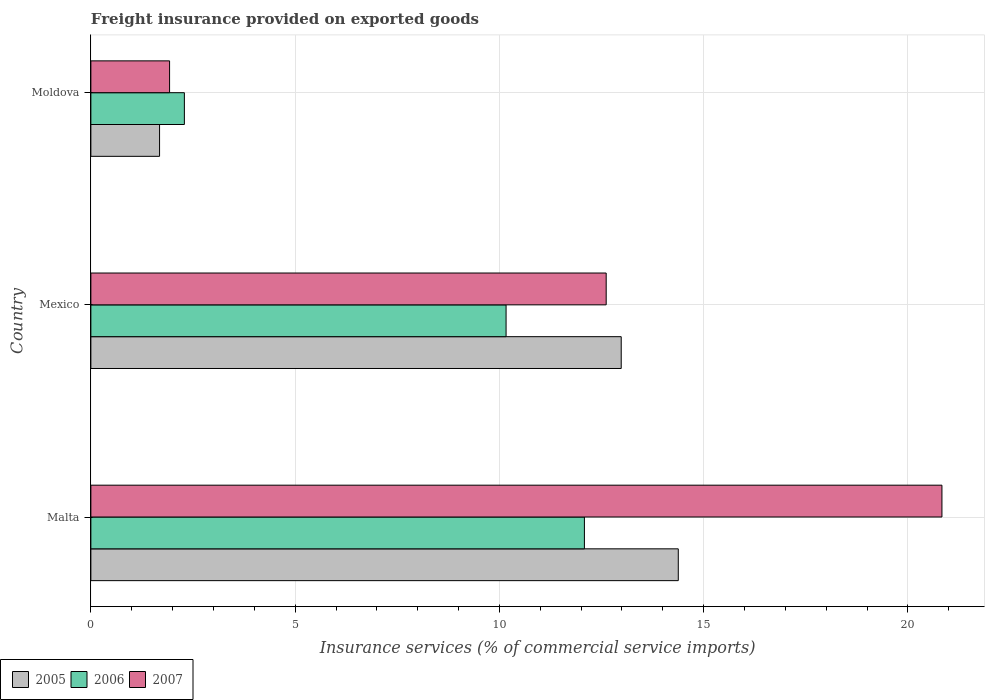How many different coloured bars are there?
Make the answer very short. 3. How many groups of bars are there?
Offer a very short reply. 3. Are the number of bars per tick equal to the number of legend labels?
Keep it short and to the point. Yes. How many bars are there on the 2nd tick from the top?
Keep it short and to the point. 3. How many bars are there on the 3rd tick from the bottom?
Your answer should be compact. 3. What is the label of the 1st group of bars from the top?
Provide a succinct answer. Moldova. In how many cases, is the number of bars for a given country not equal to the number of legend labels?
Give a very brief answer. 0. What is the freight insurance provided on exported goods in 2005 in Mexico?
Your response must be concise. 12.98. Across all countries, what is the maximum freight insurance provided on exported goods in 2006?
Offer a very short reply. 12.08. Across all countries, what is the minimum freight insurance provided on exported goods in 2007?
Ensure brevity in your answer.  1.93. In which country was the freight insurance provided on exported goods in 2007 maximum?
Ensure brevity in your answer.  Malta. In which country was the freight insurance provided on exported goods in 2006 minimum?
Your answer should be compact. Moldova. What is the total freight insurance provided on exported goods in 2006 in the graph?
Offer a terse response. 24.53. What is the difference between the freight insurance provided on exported goods in 2006 in Malta and that in Mexico?
Make the answer very short. 1.92. What is the difference between the freight insurance provided on exported goods in 2007 in Moldova and the freight insurance provided on exported goods in 2005 in Malta?
Keep it short and to the point. -12.45. What is the average freight insurance provided on exported goods in 2006 per country?
Offer a very short reply. 8.18. What is the difference between the freight insurance provided on exported goods in 2005 and freight insurance provided on exported goods in 2007 in Malta?
Make the answer very short. -6.45. In how many countries, is the freight insurance provided on exported goods in 2007 greater than 9 %?
Your answer should be compact. 2. What is the ratio of the freight insurance provided on exported goods in 2007 in Malta to that in Mexico?
Give a very brief answer. 1.65. What is the difference between the highest and the second highest freight insurance provided on exported goods in 2005?
Ensure brevity in your answer.  1.4. What is the difference between the highest and the lowest freight insurance provided on exported goods in 2006?
Ensure brevity in your answer.  9.79. In how many countries, is the freight insurance provided on exported goods in 2005 greater than the average freight insurance provided on exported goods in 2005 taken over all countries?
Ensure brevity in your answer.  2. What does the 3rd bar from the top in Moldova represents?
Provide a succinct answer. 2005. What does the 3rd bar from the bottom in Mexico represents?
Keep it short and to the point. 2007. How many bars are there?
Keep it short and to the point. 9. Does the graph contain any zero values?
Provide a succinct answer. No. Does the graph contain grids?
Your answer should be compact. Yes. What is the title of the graph?
Provide a succinct answer. Freight insurance provided on exported goods. Does "1989" appear as one of the legend labels in the graph?
Ensure brevity in your answer.  No. What is the label or title of the X-axis?
Keep it short and to the point. Insurance services (% of commercial service imports). What is the Insurance services (% of commercial service imports) in 2005 in Malta?
Offer a terse response. 14.38. What is the Insurance services (% of commercial service imports) of 2006 in Malta?
Keep it short and to the point. 12.08. What is the Insurance services (% of commercial service imports) in 2007 in Malta?
Your answer should be compact. 20.83. What is the Insurance services (% of commercial service imports) of 2005 in Mexico?
Provide a short and direct response. 12.98. What is the Insurance services (% of commercial service imports) of 2006 in Mexico?
Your answer should be compact. 10.16. What is the Insurance services (% of commercial service imports) in 2007 in Mexico?
Ensure brevity in your answer.  12.61. What is the Insurance services (% of commercial service imports) in 2005 in Moldova?
Offer a very short reply. 1.68. What is the Insurance services (% of commercial service imports) of 2006 in Moldova?
Your answer should be very brief. 2.29. What is the Insurance services (% of commercial service imports) of 2007 in Moldova?
Ensure brevity in your answer.  1.93. Across all countries, what is the maximum Insurance services (% of commercial service imports) in 2005?
Make the answer very short. 14.38. Across all countries, what is the maximum Insurance services (% of commercial service imports) of 2006?
Your answer should be compact. 12.08. Across all countries, what is the maximum Insurance services (% of commercial service imports) of 2007?
Offer a very short reply. 20.83. Across all countries, what is the minimum Insurance services (% of commercial service imports) of 2005?
Your response must be concise. 1.68. Across all countries, what is the minimum Insurance services (% of commercial service imports) of 2006?
Provide a succinct answer. 2.29. Across all countries, what is the minimum Insurance services (% of commercial service imports) in 2007?
Your response must be concise. 1.93. What is the total Insurance services (% of commercial service imports) in 2005 in the graph?
Your answer should be very brief. 29.04. What is the total Insurance services (% of commercial service imports) of 2006 in the graph?
Ensure brevity in your answer.  24.53. What is the total Insurance services (% of commercial service imports) of 2007 in the graph?
Keep it short and to the point. 35.37. What is the difference between the Insurance services (% of commercial service imports) in 2005 in Malta and that in Mexico?
Provide a succinct answer. 1.4. What is the difference between the Insurance services (% of commercial service imports) in 2006 in Malta and that in Mexico?
Offer a very short reply. 1.92. What is the difference between the Insurance services (% of commercial service imports) of 2007 in Malta and that in Mexico?
Offer a very short reply. 8.22. What is the difference between the Insurance services (% of commercial service imports) in 2005 in Malta and that in Moldova?
Make the answer very short. 12.7. What is the difference between the Insurance services (% of commercial service imports) of 2006 in Malta and that in Moldova?
Offer a terse response. 9.79. What is the difference between the Insurance services (% of commercial service imports) in 2007 in Malta and that in Moldova?
Provide a short and direct response. 18.91. What is the difference between the Insurance services (% of commercial service imports) in 2005 in Mexico and that in Moldova?
Your response must be concise. 11.3. What is the difference between the Insurance services (% of commercial service imports) of 2006 in Mexico and that in Moldova?
Ensure brevity in your answer.  7.87. What is the difference between the Insurance services (% of commercial service imports) in 2007 in Mexico and that in Moldova?
Offer a terse response. 10.69. What is the difference between the Insurance services (% of commercial service imports) of 2005 in Malta and the Insurance services (% of commercial service imports) of 2006 in Mexico?
Ensure brevity in your answer.  4.22. What is the difference between the Insurance services (% of commercial service imports) in 2005 in Malta and the Insurance services (% of commercial service imports) in 2007 in Mexico?
Provide a succinct answer. 1.76. What is the difference between the Insurance services (% of commercial service imports) in 2006 in Malta and the Insurance services (% of commercial service imports) in 2007 in Mexico?
Your response must be concise. -0.53. What is the difference between the Insurance services (% of commercial service imports) in 2005 in Malta and the Insurance services (% of commercial service imports) in 2006 in Moldova?
Give a very brief answer. 12.09. What is the difference between the Insurance services (% of commercial service imports) in 2005 in Malta and the Insurance services (% of commercial service imports) in 2007 in Moldova?
Ensure brevity in your answer.  12.45. What is the difference between the Insurance services (% of commercial service imports) of 2006 in Malta and the Insurance services (% of commercial service imports) of 2007 in Moldova?
Provide a short and direct response. 10.15. What is the difference between the Insurance services (% of commercial service imports) of 2005 in Mexico and the Insurance services (% of commercial service imports) of 2006 in Moldova?
Provide a short and direct response. 10.69. What is the difference between the Insurance services (% of commercial service imports) of 2005 in Mexico and the Insurance services (% of commercial service imports) of 2007 in Moldova?
Keep it short and to the point. 11.06. What is the difference between the Insurance services (% of commercial service imports) in 2006 in Mexico and the Insurance services (% of commercial service imports) in 2007 in Moldova?
Your answer should be compact. 8.24. What is the average Insurance services (% of commercial service imports) in 2005 per country?
Ensure brevity in your answer.  9.68. What is the average Insurance services (% of commercial service imports) in 2006 per country?
Ensure brevity in your answer.  8.18. What is the average Insurance services (% of commercial service imports) of 2007 per country?
Ensure brevity in your answer.  11.79. What is the difference between the Insurance services (% of commercial service imports) of 2005 and Insurance services (% of commercial service imports) of 2006 in Malta?
Offer a very short reply. 2.3. What is the difference between the Insurance services (% of commercial service imports) of 2005 and Insurance services (% of commercial service imports) of 2007 in Malta?
Your answer should be very brief. -6.45. What is the difference between the Insurance services (% of commercial service imports) of 2006 and Insurance services (% of commercial service imports) of 2007 in Malta?
Your answer should be very brief. -8.75. What is the difference between the Insurance services (% of commercial service imports) of 2005 and Insurance services (% of commercial service imports) of 2006 in Mexico?
Your answer should be compact. 2.82. What is the difference between the Insurance services (% of commercial service imports) of 2005 and Insurance services (% of commercial service imports) of 2007 in Mexico?
Ensure brevity in your answer.  0.37. What is the difference between the Insurance services (% of commercial service imports) in 2006 and Insurance services (% of commercial service imports) in 2007 in Mexico?
Make the answer very short. -2.45. What is the difference between the Insurance services (% of commercial service imports) of 2005 and Insurance services (% of commercial service imports) of 2006 in Moldova?
Offer a terse response. -0.61. What is the difference between the Insurance services (% of commercial service imports) in 2005 and Insurance services (% of commercial service imports) in 2007 in Moldova?
Your answer should be very brief. -0.25. What is the difference between the Insurance services (% of commercial service imports) of 2006 and Insurance services (% of commercial service imports) of 2007 in Moldova?
Your response must be concise. 0.36. What is the ratio of the Insurance services (% of commercial service imports) in 2005 in Malta to that in Mexico?
Your answer should be compact. 1.11. What is the ratio of the Insurance services (% of commercial service imports) of 2006 in Malta to that in Mexico?
Make the answer very short. 1.19. What is the ratio of the Insurance services (% of commercial service imports) of 2007 in Malta to that in Mexico?
Offer a terse response. 1.65. What is the ratio of the Insurance services (% of commercial service imports) of 2005 in Malta to that in Moldova?
Provide a succinct answer. 8.55. What is the ratio of the Insurance services (% of commercial service imports) of 2006 in Malta to that in Moldova?
Provide a succinct answer. 5.28. What is the ratio of the Insurance services (% of commercial service imports) in 2007 in Malta to that in Moldova?
Keep it short and to the point. 10.82. What is the ratio of the Insurance services (% of commercial service imports) of 2005 in Mexico to that in Moldova?
Offer a terse response. 7.72. What is the ratio of the Insurance services (% of commercial service imports) in 2006 in Mexico to that in Moldova?
Offer a very short reply. 4.44. What is the ratio of the Insurance services (% of commercial service imports) of 2007 in Mexico to that in Moldova?
Give a very brief answer. 6.55. What is the difference between the highest and the second highest Insurance services (% of commercial service imports) in 2005?
Provide a succinct answer. 1.4. What is the difference between the highest and the second highest Insurance services (% of commercial service imports) of 2006?
Your answer should be compact. 1.92. What is the difference between the highest and the second highest Insurance services (% of commercial service imports) in 2007?
Ensure brevity in your answer.  8.22. What is the difference between the highest and the lowest Insurance services (% of commercial service imports) in 2005?
Your answer should be very brief. 12.7. What is the difference between the highest and the lowest Insurance services (% of commercial service imports) in 2006?
Your answer should be compact. 9.79. What is the difference between the highest and the lowest Insurance services (% of commercial service imports) in 2007?
Your answer should be very brief. 18.91. 